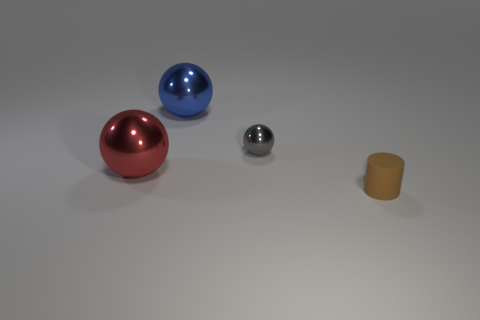Add 2 small gray metal objects. How many objects exist? 6 Subtract all cylinders. How many objects are left? 3 Add 4 brown cylinders. How many brown cylinders exist? 5 Subtract 0 green spheres. How many objects are left? 4 Subtract all tiny cubes. Subtract all blue shiny things. How many objects are left? 3 Add 2 large blue spheres. How many large blue spheres are left? 3 